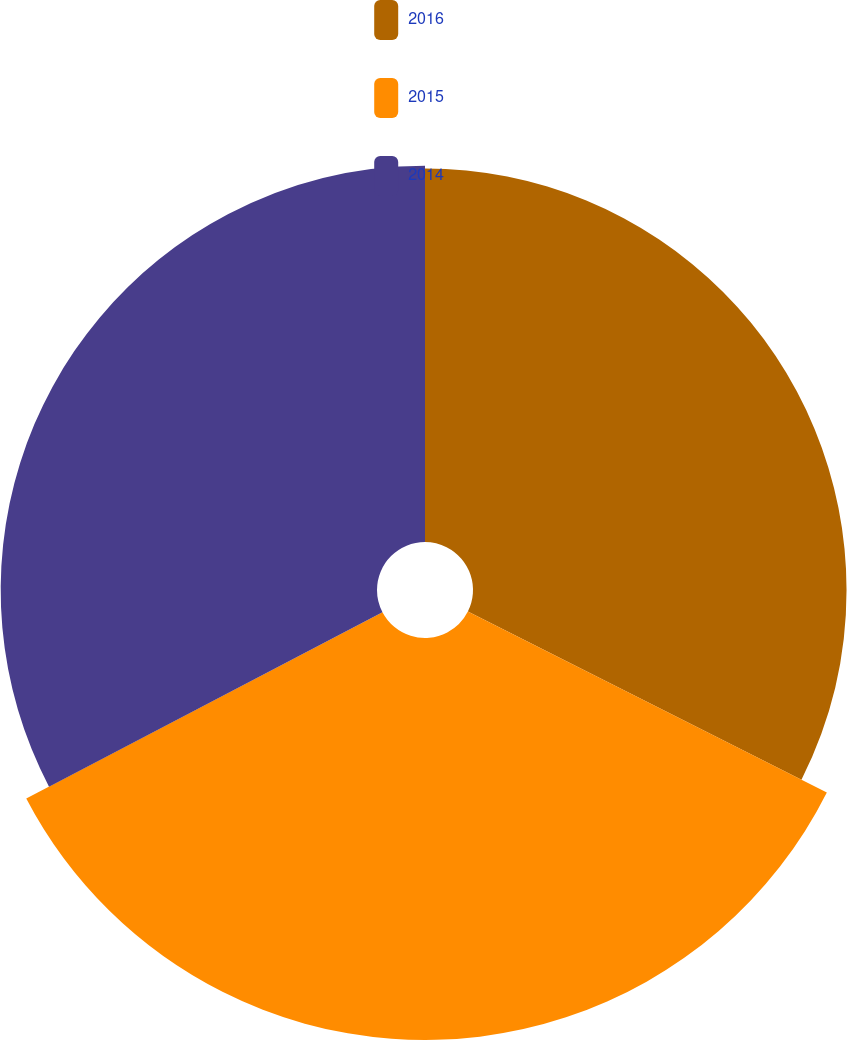Convert chart to OTSL. <chart><loc_0><loc_0><loc_500><loc_500><pie_chart><fcel>2016<fcel>2015<fcel>2014<nl><fcel>32.43%<fcel>34.9%<fcel>32.67%<nl></chart> 